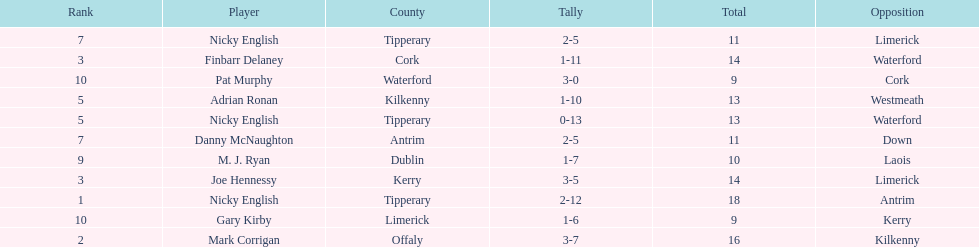Could you parse the entire table? {'header': ['Rank', 'Player', 'County', 'Tally', 'Total', 'Opposition'], 'rows': [['7', 'Nicky English', 'Tipperary', '2-5', '11', 'Limerick'], ['3', 'Finbarr Delaney', 'Cork', '1-11', '14', 'Waterford'], ['10', 'Pat Murphy', 'Waterford', '3-0', '9', 'Cork'], ['5', 'Adrian Ronan', 'Kilkenny', '1-10', '13', 'Westmeath'], ['5', 'Nicky English', 'Tipperary', '0-13', '13', 'Waterford'], ['7', 'Danny McNaughton', 'Antrim', '2-5', '11', 'Down'], ['9', 'M. J. Ryan', 'Dublin', '1-7', '10', 'Laois'], ['3', 'Joe Hennessy', 'Kerry', '3-5', '14', 'Limerick'], ['1', 'Nicky English', 'Tipperary', '2-12', '18', 'Antrim'], ['10', 'Gary Kirby', 'Limerick', '1-6', '9', 'Kerry'], ['2', 'Mark Corrigan', 'Offaly', '3-7', '16', 'Kilkenny']]} If you combined all the total's, what would the amount be? 138. 